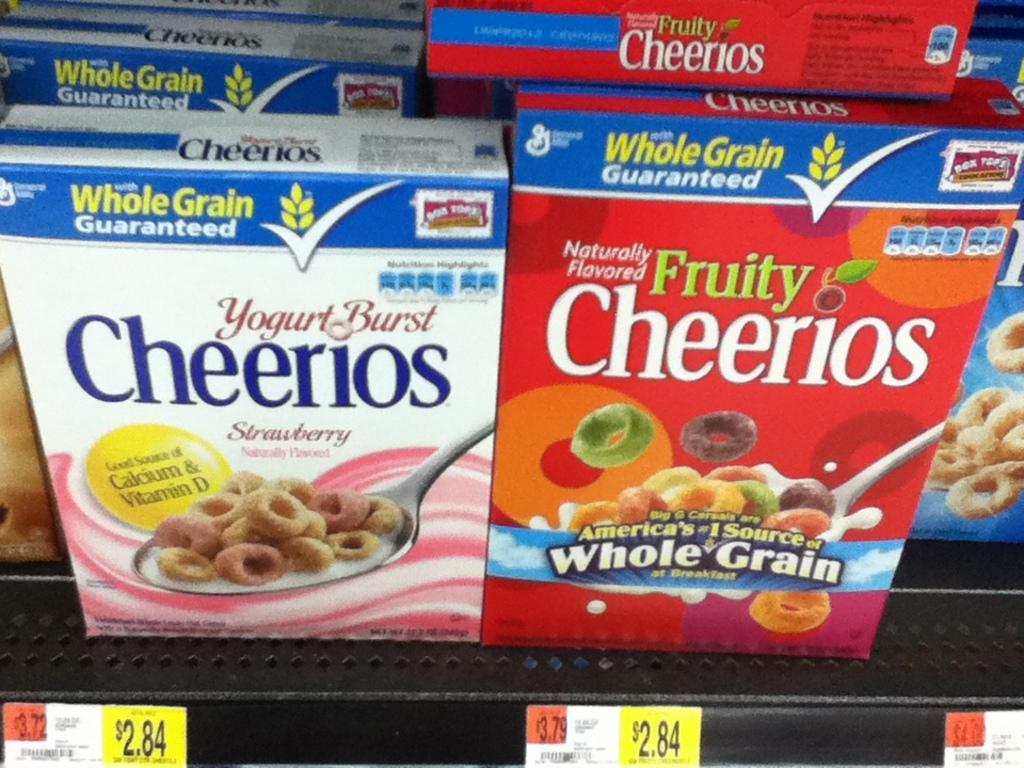Please provide a concise description of this image. In this picture I can see the boxes of the food items, on the rack and there are price boards. 